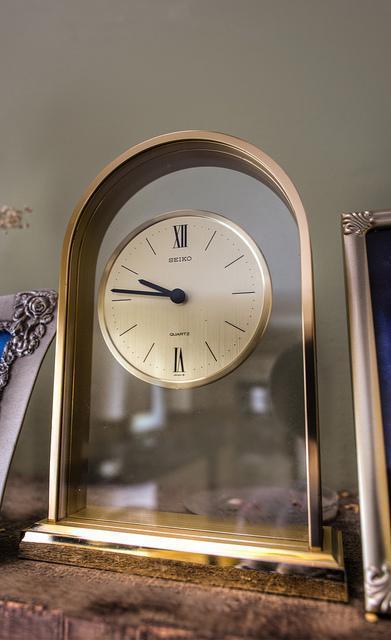How many barefoot people are in the picture?
Give a very brief answer. 0. 